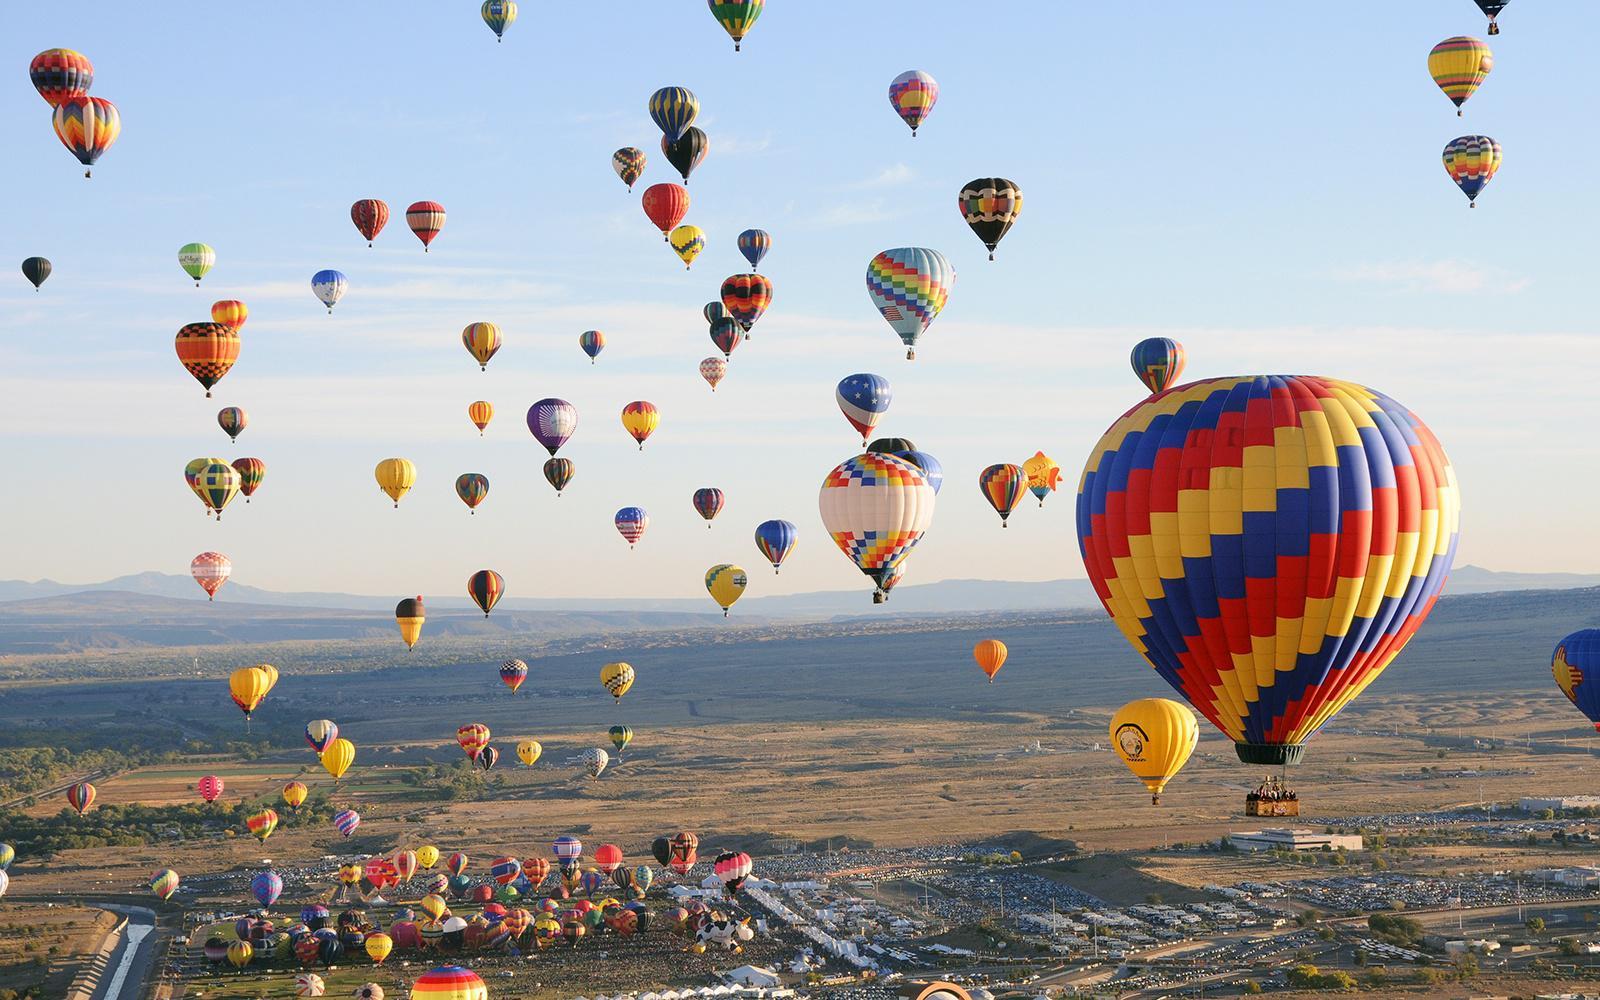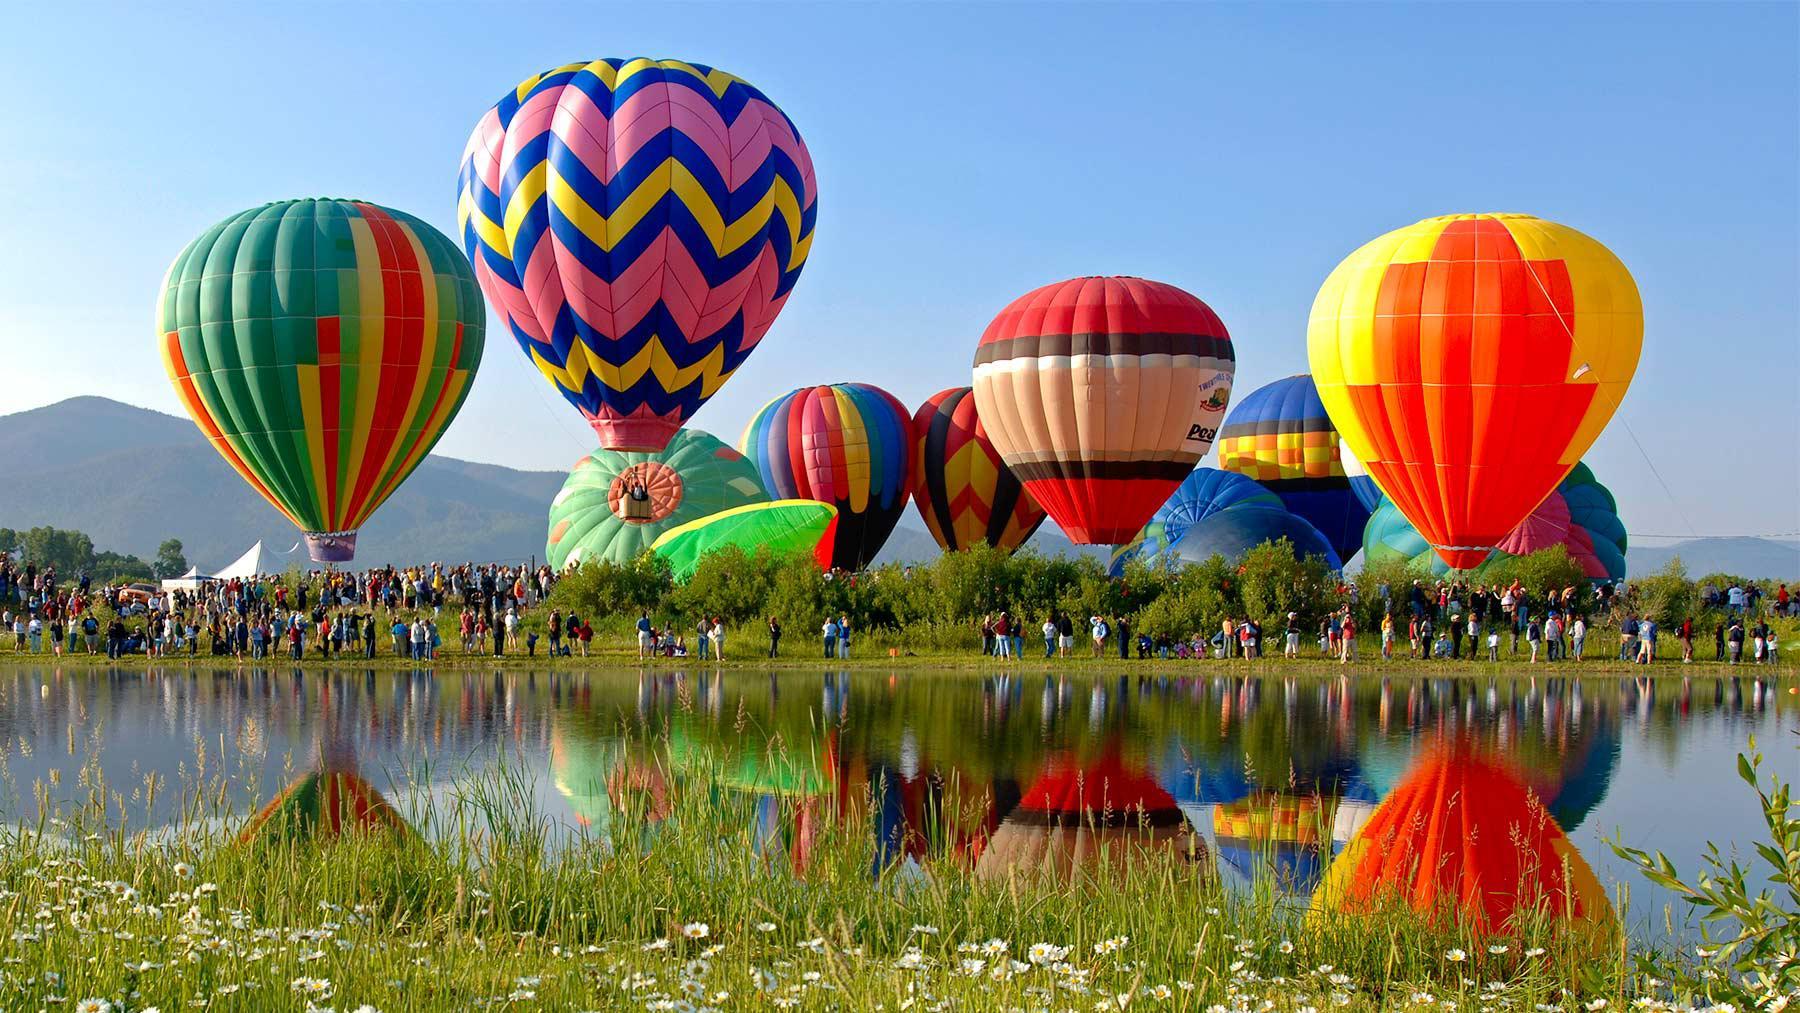The first image is the image on the left, the second image is the image on the right. Analyze the images presented: Is the assertion "There are hot air balloons floating over a body of water in the right image." valid? Answer yes or no. Yes. The first image is the image on the left, the second image is the image on the right. Analyze the images presented: Is the assertion "At least one balloon is shaped like an animal with legs." valid? Answer yes or no. No. 